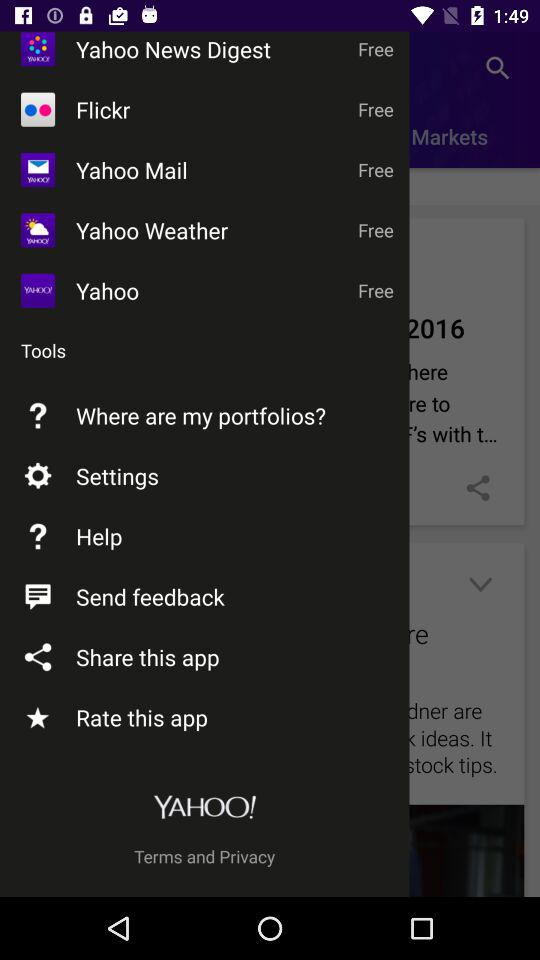How many notifications are there in "Settings"?
When the provided information is insufficient, respond with <no answer>. <no answer> 